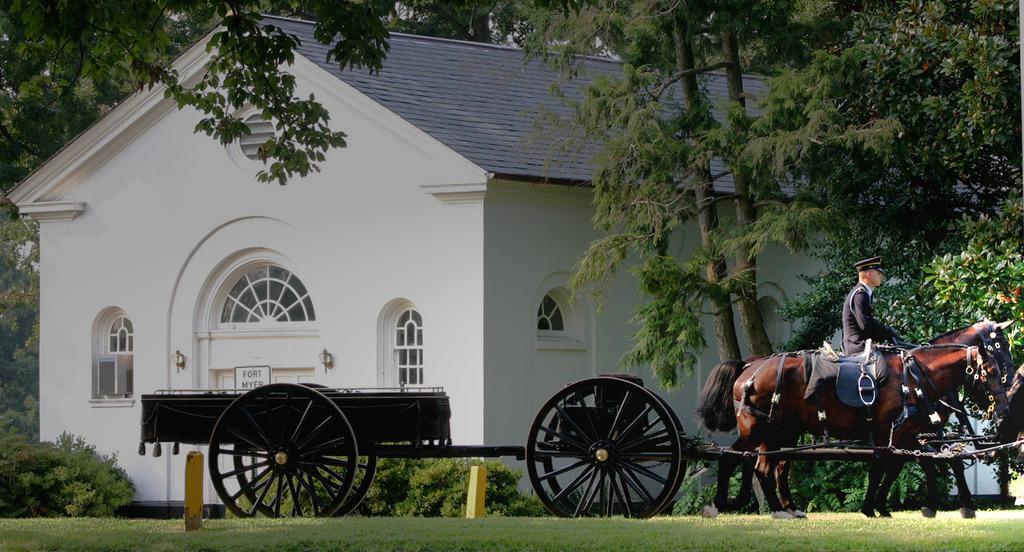How would you summarize this image in a sentence or two? In this picture we can see a horse cart, there is a person sitting on a horse, at the bottom there is grass, we can see a house, trees and plants in the background, we can see windows here. 